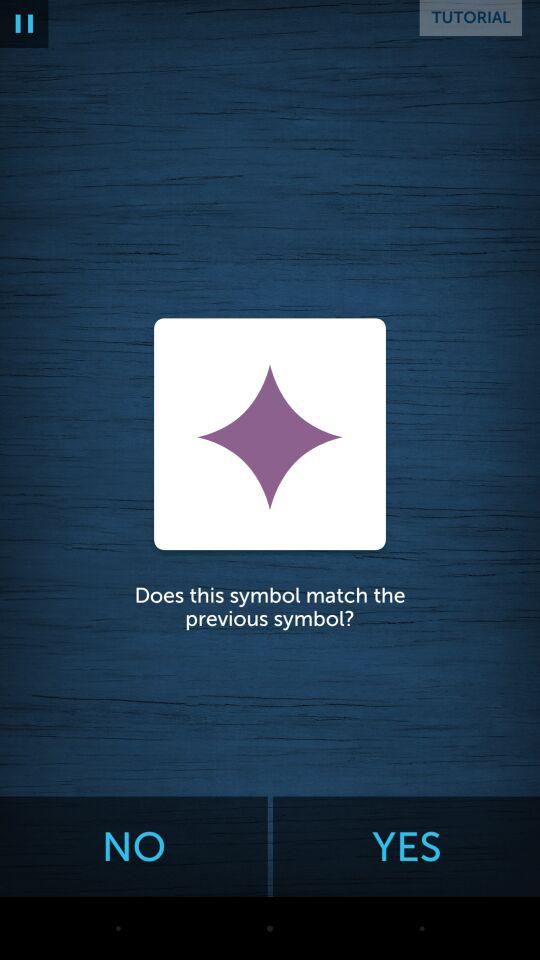How many steps are there in the test?
Answer the question using a single word or phrase. 3 